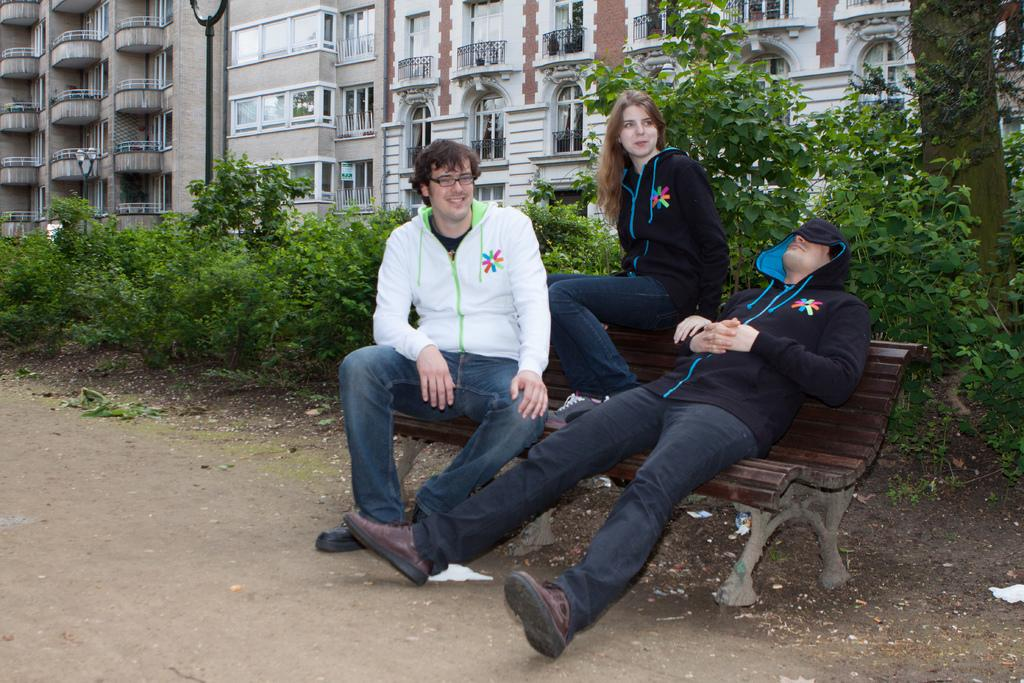How many people are in the image? There are two men and a woman in the image. What are the people in the image doing? They are sitting on a bench. What can be seen in the background of the image? There are plants, a tree, and a building in the background of the image. What type of business is being conducted on the bench in the image? There is no indication of any business being conducted in the image; the people are simply sitting on a bench. Are the people in the image sleeping? No, the people in the image are sitting on a bench, not sleeping. 